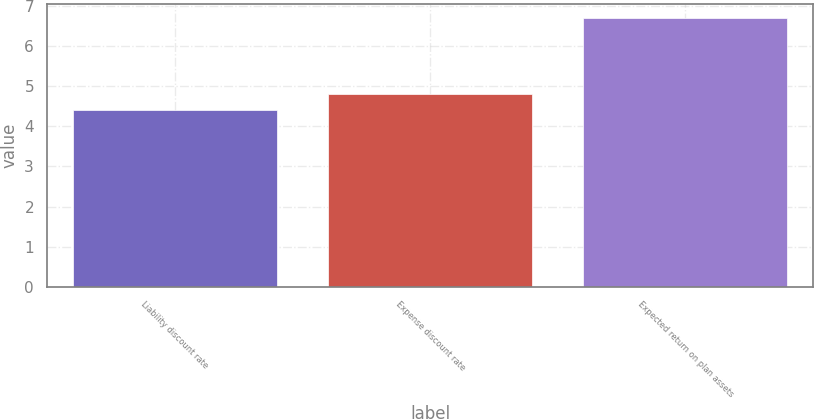Convert chart. <chart><loc_0><loc_0><loc_500><loc_500><bar_chart><fcel>Liability discount rate<fcel>Expense discount rate<fcel>Expected return on plan assets<nl><fcel>4.4<fcel>4.8<fcel>6.7<nl></chart> 